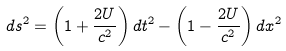Convert formula to latex. <formula><loc_0><loc_0><loc_500><loc_500>d s ^ { 2 } = \left ( 1 + \frac { 2 U } { c ^ { 2 } } \right ) d t ^ { 2 } - \left ( 1 - \frac { 2 U } { c ^ { 2 } } \right ) d x ^ { 2 }</formula> 